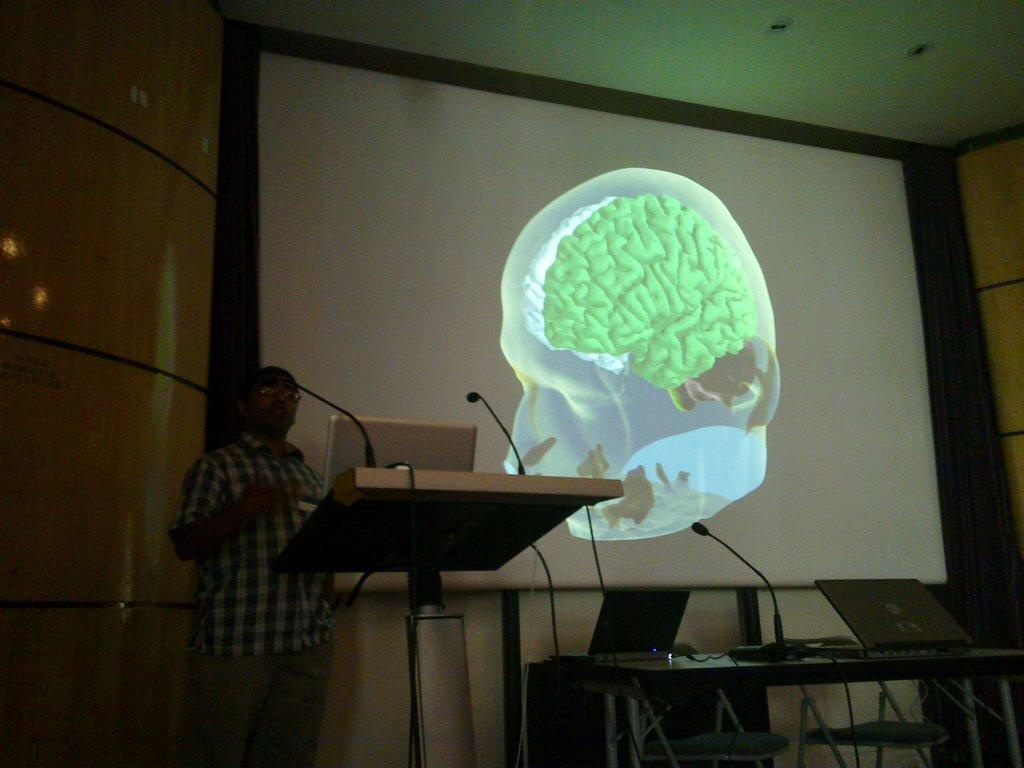What is located in the foreground of the picture? In the foreground of the picture, there are mice, chairs, a table, laptops, a podium, and a person standing. What objects are present on the table in the foreground? The table in the foreground has laptops on it. What is the person standing in the foreground doing? The person standing in the foreground is likely presenting or speaking, as there is a podium nearby. What can be seen in the background of the picture? In the background of the picture, there is a projector screen. What part of the room is visible at the top of the image? The ceiling is visible at the top of the image. What is the name of the baseball player in the picture? There is no baseball player present in the image; it features mice, chairs, a table, laptops, a podium, and a person standing. How many hands does the person in the picture have? The person in the picture has two hands, as is typical for humans. 